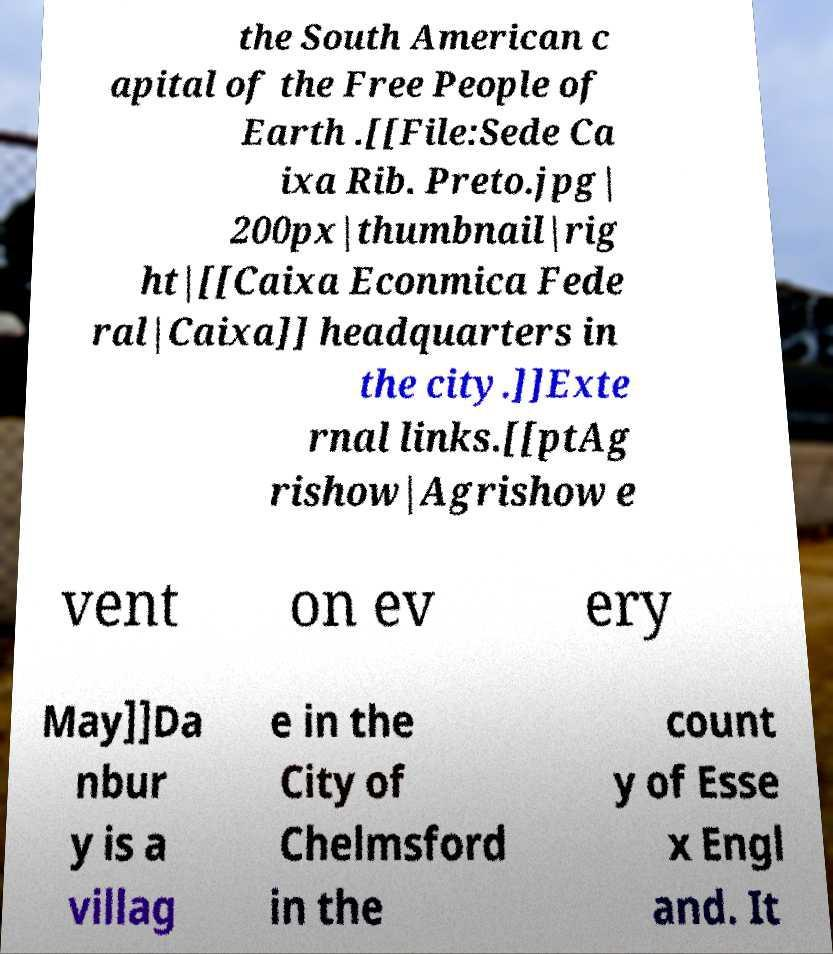What messages or text are displayed in this image? I need them in a readable, typed format. the South American c apital of the Free People of Earth .[[File:Sede Ca ixa Rib. Preto.jpg| 200px|thumbnail|rig ht|[[Caixa Econmica Fede ral|Caixa]] headquarters in the city.]]Exte rnal links.[[ptAg rishow|Agrishow e vent on ev ery May]]Da nbur y is a villag e in the City of Chelmsford in the count y of Esse x Engl and. It 